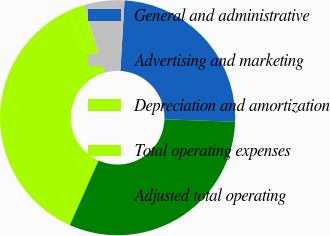<chart> <loc_0><loc_0><loc_500><loc_500><pie_chart><fcel>General and administrative<fcel>Advertising and marketing<fcel>Depreciation and amortization<fcel>Total operating expenses<fcel>Adjusted total operating<nl><fcel>24.61%<fcel>5.61%<fcel>2.18%<fcel>36.48%<fcel>31.11%<nl></chart> 